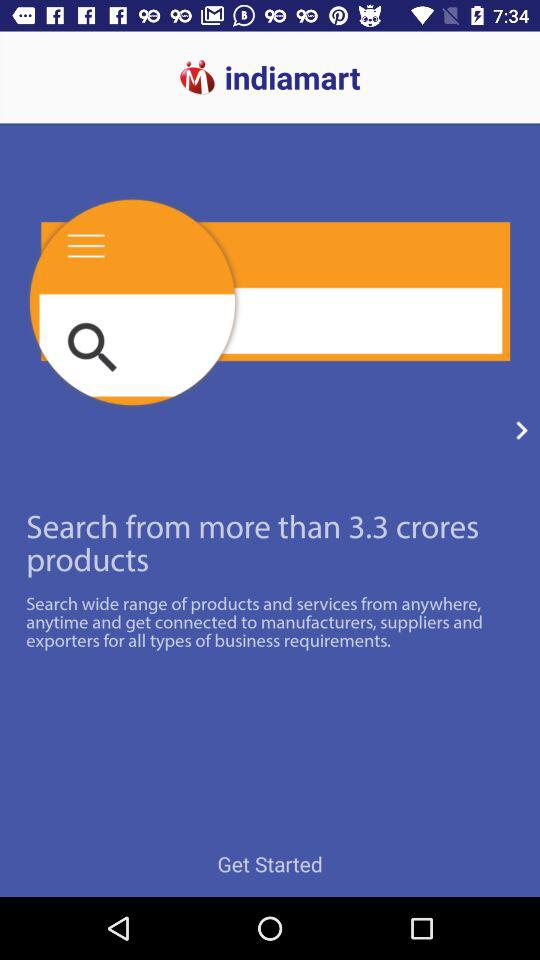What is the application name? The application name is "indiamart". 